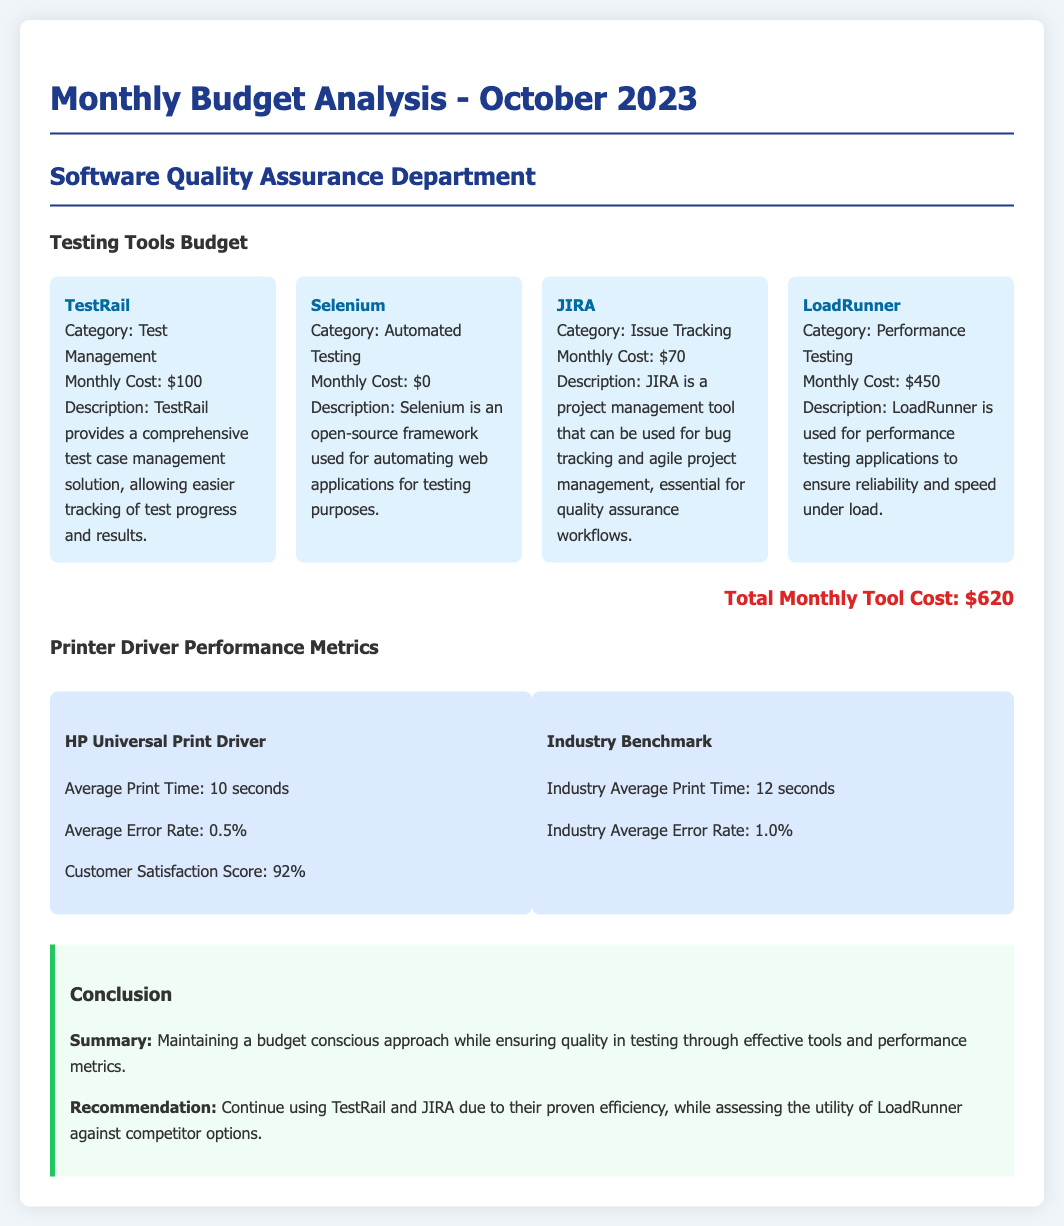What is the total monthly tool cost? The total monthly tool cost is calculated by summing the costs of all listed software testing tools, resulting in $620.
Answer: $620 What are the metrics for the HP Universal Print Driver's average error rate? The average error rate for the HP Universal Print Driver is explicitly stated in the document.
Answer: 0.5% What is the monthly cost of LoadRunner? LoadRunner's monthly cost is presented in the document as $450.
Answer: $450 What is the customer satisfaction score for the HP Universal Print Driver? The document provides a specific customer satisfaction score of the HP Universal Print Driver.
Answer: 92% Who is the author of the report? The document indicates that it is from the Software Quality Assurance Department, highlighting its focus.
Answer: Software Quality Assurance Department What is the average print time for the industry benchmark? The average print time for the industry benchmark is mentioned and compared with the HP Universal Print Driver.
Answer: 12 seconds Which tools are recommended to continue using? The document explicitly states which tools should continue being used based on efficiency, combining insights from multiple sections.
Answer: TestRail and JIRA What is the description of Selenium? The document provides a succinct description explaining what Selenium is used for within the context of the report.
Answer: Selenium is an open-source framework used for automating web applications for testing purposes What is the average print time for the HP Universal Print Driver? The document specifies the HP Universal Print Driver's average print time as part of its performance metrics.
Answer: 10 seconds 